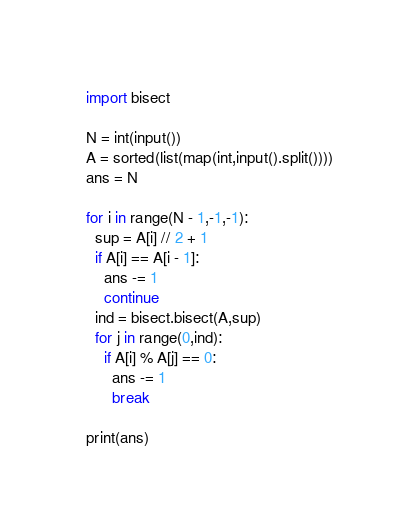<code> <loc_0><loc_0><loc_500><loc_500><_Python_>import bisect

N = int(input())
A = sorted(list(map(int,input().split())))
ans = N

for i in range(N - 1,-1,-1):
  sup = A[i] // 2 + 1
  if A[i] == A[i - 1]:
    ans -= 1
    continue
  ind = bisect.bisect(A,sup)
  for j in range(0,ind):
    if A[i] % A[j] == 0:
      ans -= 1
      break

print(ans)</code> 